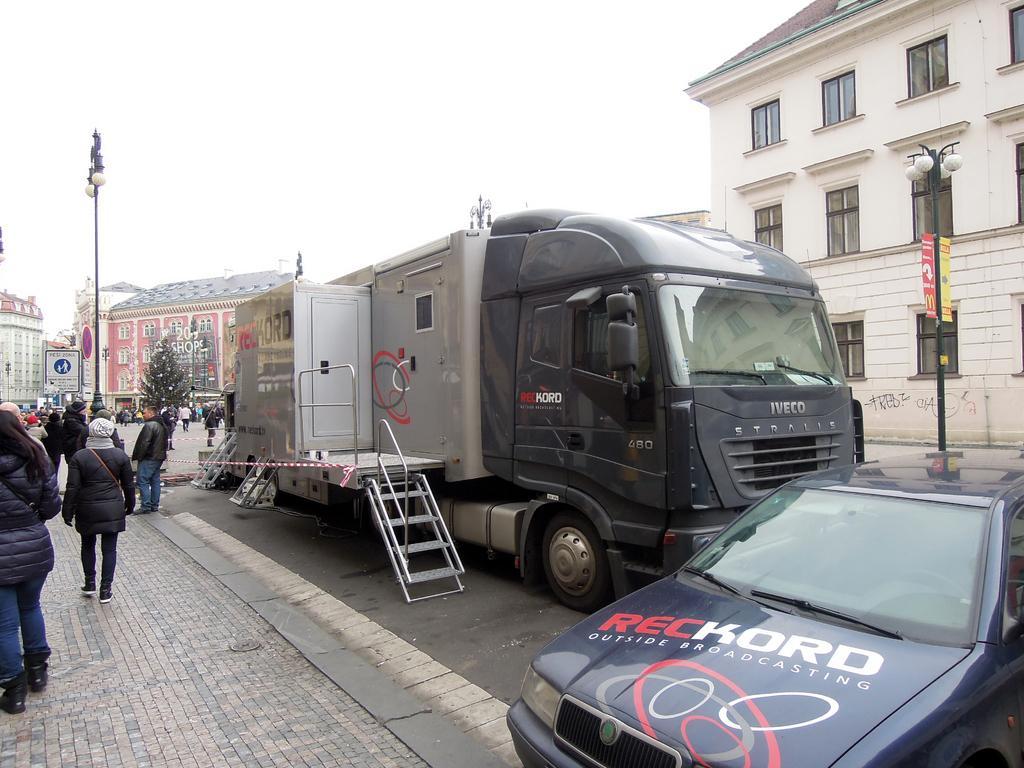In one or two sentences, can you explain what this image depicts? This image is taken outdoors. At the bottom of the image there is a floor and a road. On the right side of the image a car is parked on the road. In the middle of the image a truck is parked on the road. In the background there are a few buildings and poles with street lights. There is a tree and there are a few boards with text on them. On the left side of the image a few people are walking on the sidewalk. 